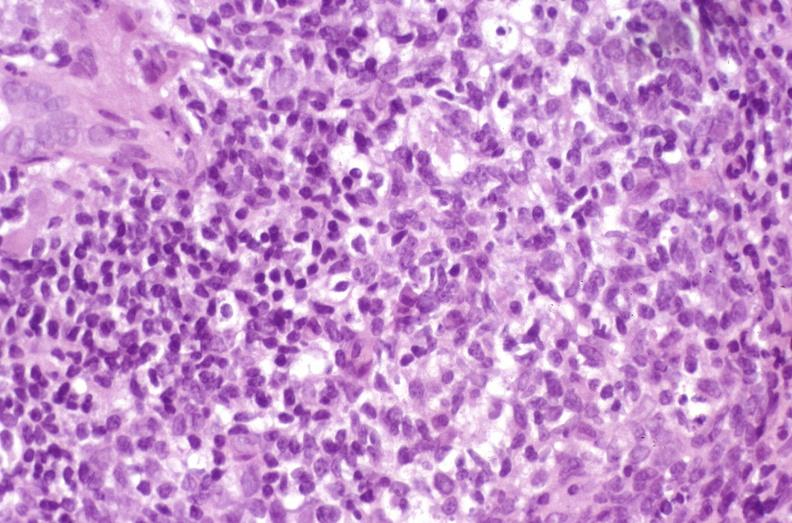what is present?
Answer the question using a single word or phrase. Hepatobiliary 